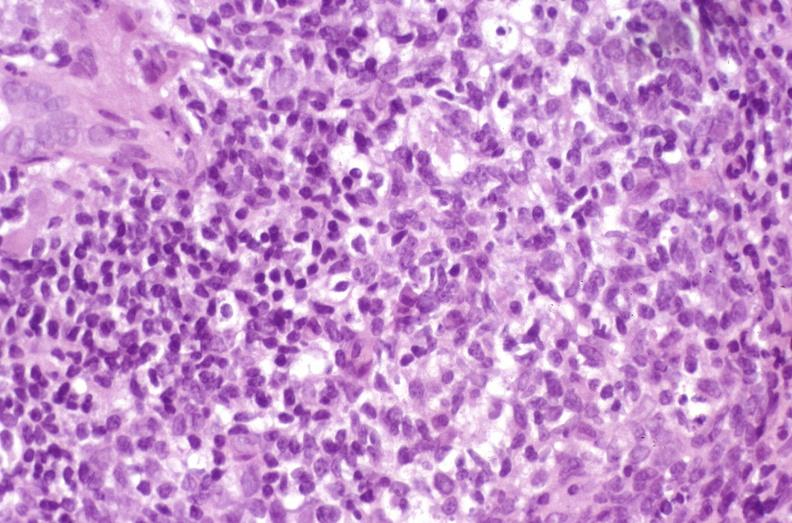what is present?
Answer the question using a single word or phrase. Hepatobiliary 